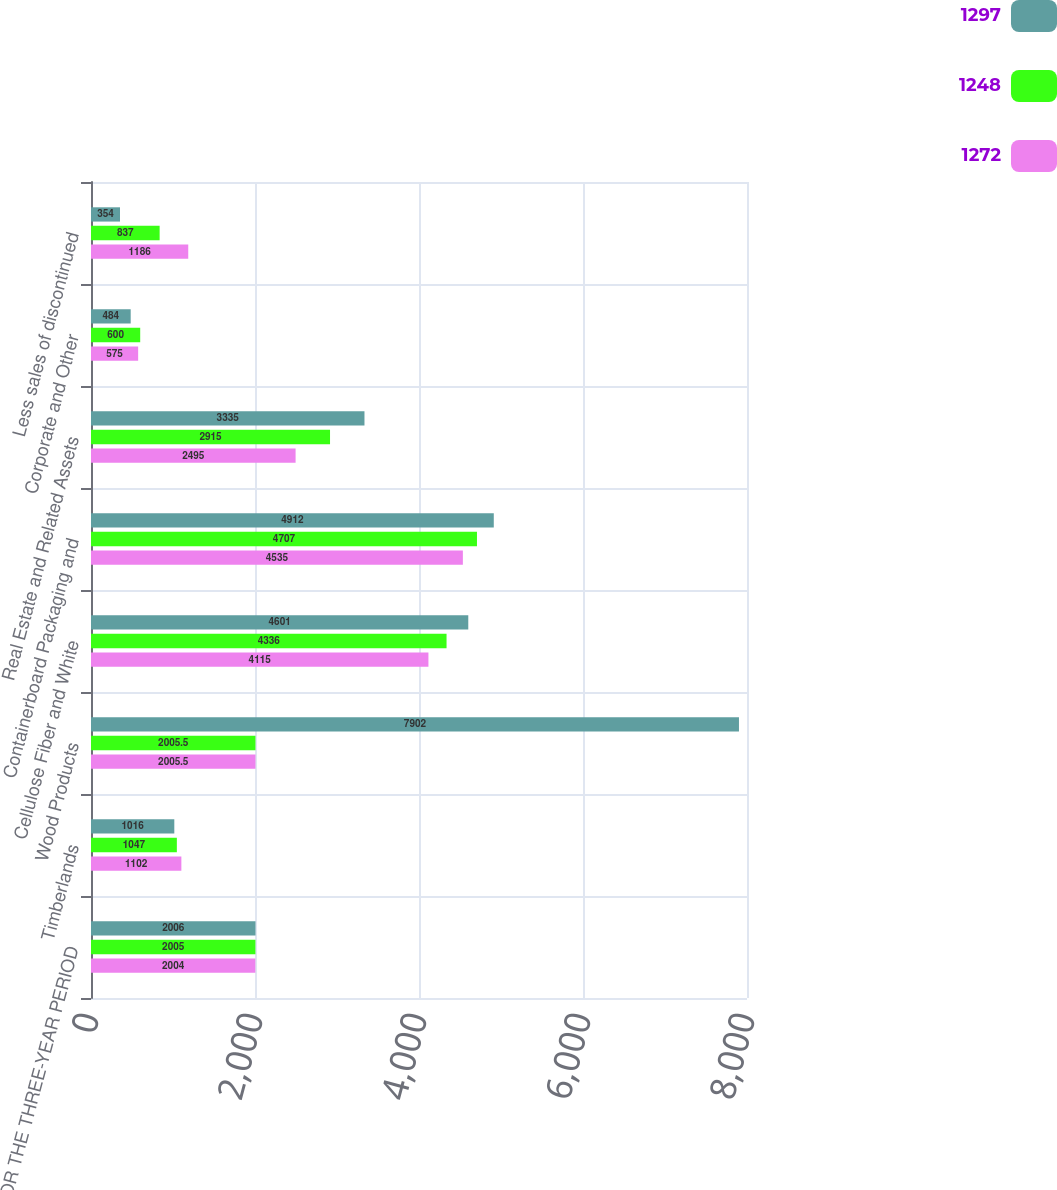<chart> <loc_0><loc_0><loc_500><loc_500><stacked_bar_chart><ecel><fcel>FOR THE THREE-YEAR PERIOD<fcel>Timberlands<fcel>Wood Products<fcel>Cellulose Fiber and White<fcel>Containerboard Packaging and<fcel>Real Estate and Related Assets<fcel>Corporate and Other<fcel>Less sales of discontinued<nl><fcel>1297<fcel>2006<fcel>1016<fcel>7902<fcel>4601<fcel>4912<fcel>3335<fcel>484<fcel>354<nl><fcel>1248<fcel>2005<fcel>1047<fcel>2005.5<fcel>4336<fcel>4707<fcel>2915<fcel>600<fcel>837<nl><fcel>1272<fcel>2004<fcel>1102<fcel>2005.5<fcel>4115<fcel>4535<fcel>2495<fcel>575<fcel>1186<nl></chart> 